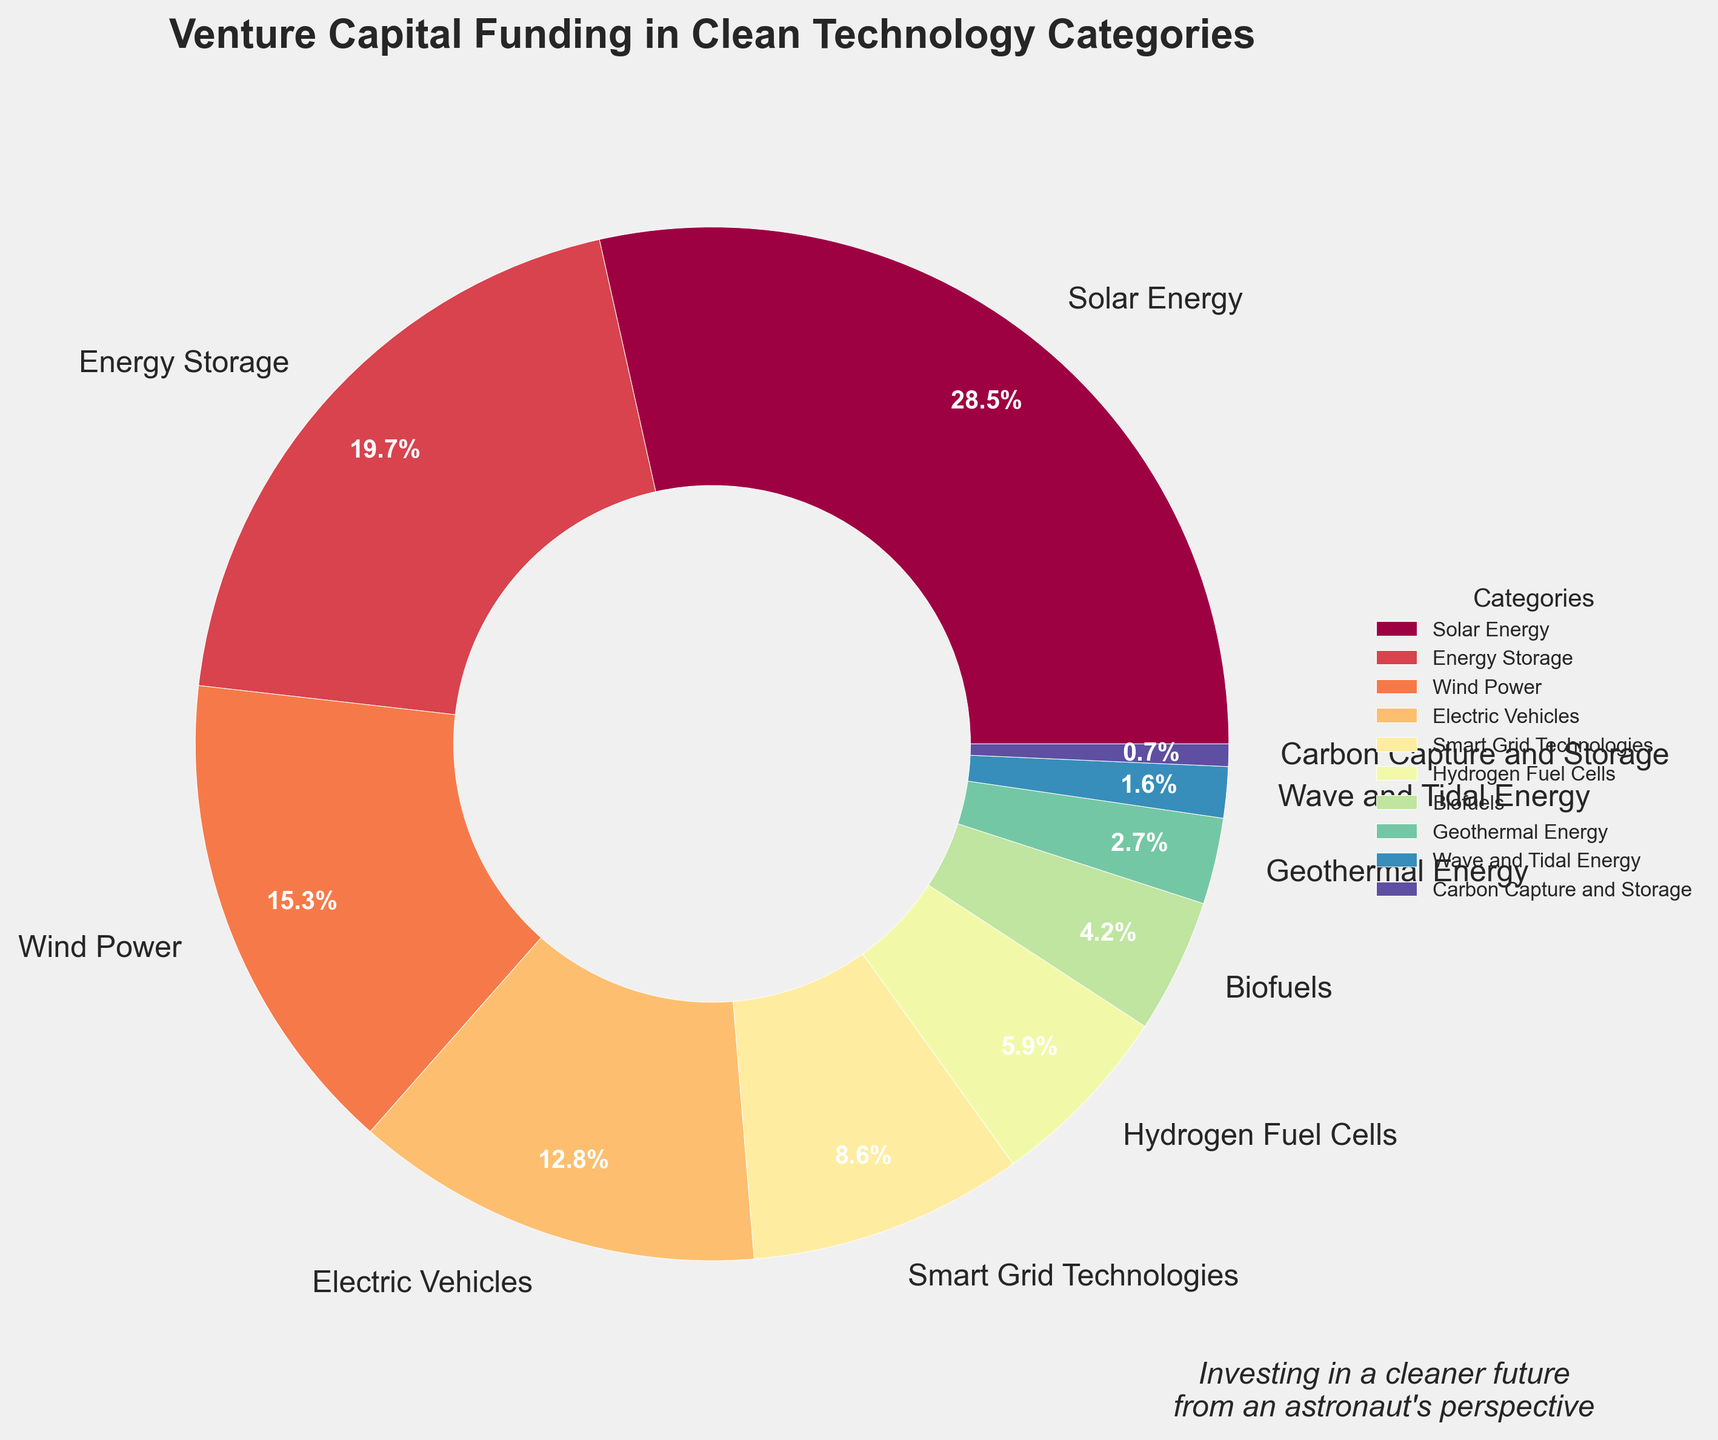Which clean technology category receives the highest percentage of venture capital funding? The largest wedge in the pie chart represents the clean technology category with the highest percentage of venture capital funding.
Answer: Solar Energy What is the combined percentage of funding for Solar Energy and Energy Storage? Sum the percentages of Solar Energy (28.5%) and Energy Storage (19.7%). 28.5 + 19.7 = 48.2%
Answer: 48.2% Which category receives slightly more funding: Wind Power or Electric Vehicles? Compare the percentages for Wind Power (15.3%) and Electric Vehicles (12.8%). Wind Power has a higher percentage.
Answer: Wind Power How much more funding does Energy Storage receive compared to Smart Grid Technologies? Subtract the percentage of Smart Grid Technologies (8.6%) from Energy Storage (19.7%). 19.7 - 8.6 = 11.1%
Answer: 11.1% How does the funding for Biofuels compare to that for Hydrogen Fuel Cells visually in the pie chart? The wedge for Hydrogen Fuel Cells is larger than the wedge for Biofuels, indicating that Hydrogen Fuel Cells receive more funding.
Answer: Hydrogen Fuel Cells receive more funding What's the combined funding percentage for categories that receive less than 5% each? Sum the percentages of Hydrogen Fuel Cells (5.9%), Biofuels (4.2%), Geothermal Energy (2.7%), Wave and Tidal Energy (1.6%), and Carbon Capture and Storage (0.7%). 5.9 + 4.2 + 2.7 + 1.6 + 0.7 = 15.1%
Answer: 15.1% Is there a large discrepancy between the funding for Solar Energy and Wave and Tidal Energy? Yes, Solar Energy receives 28.5% of funding while Wave and Tidal Energy receive only 1.6%, indicating a large discrepancy.
Answer: Yes What is the relative position (rank) of Smart Grid Technologies in terms of venture capital funding received? Smart Grid Technologies receives 8.6% of the funding, making it the fifth largest category.
Answer: Fifth 